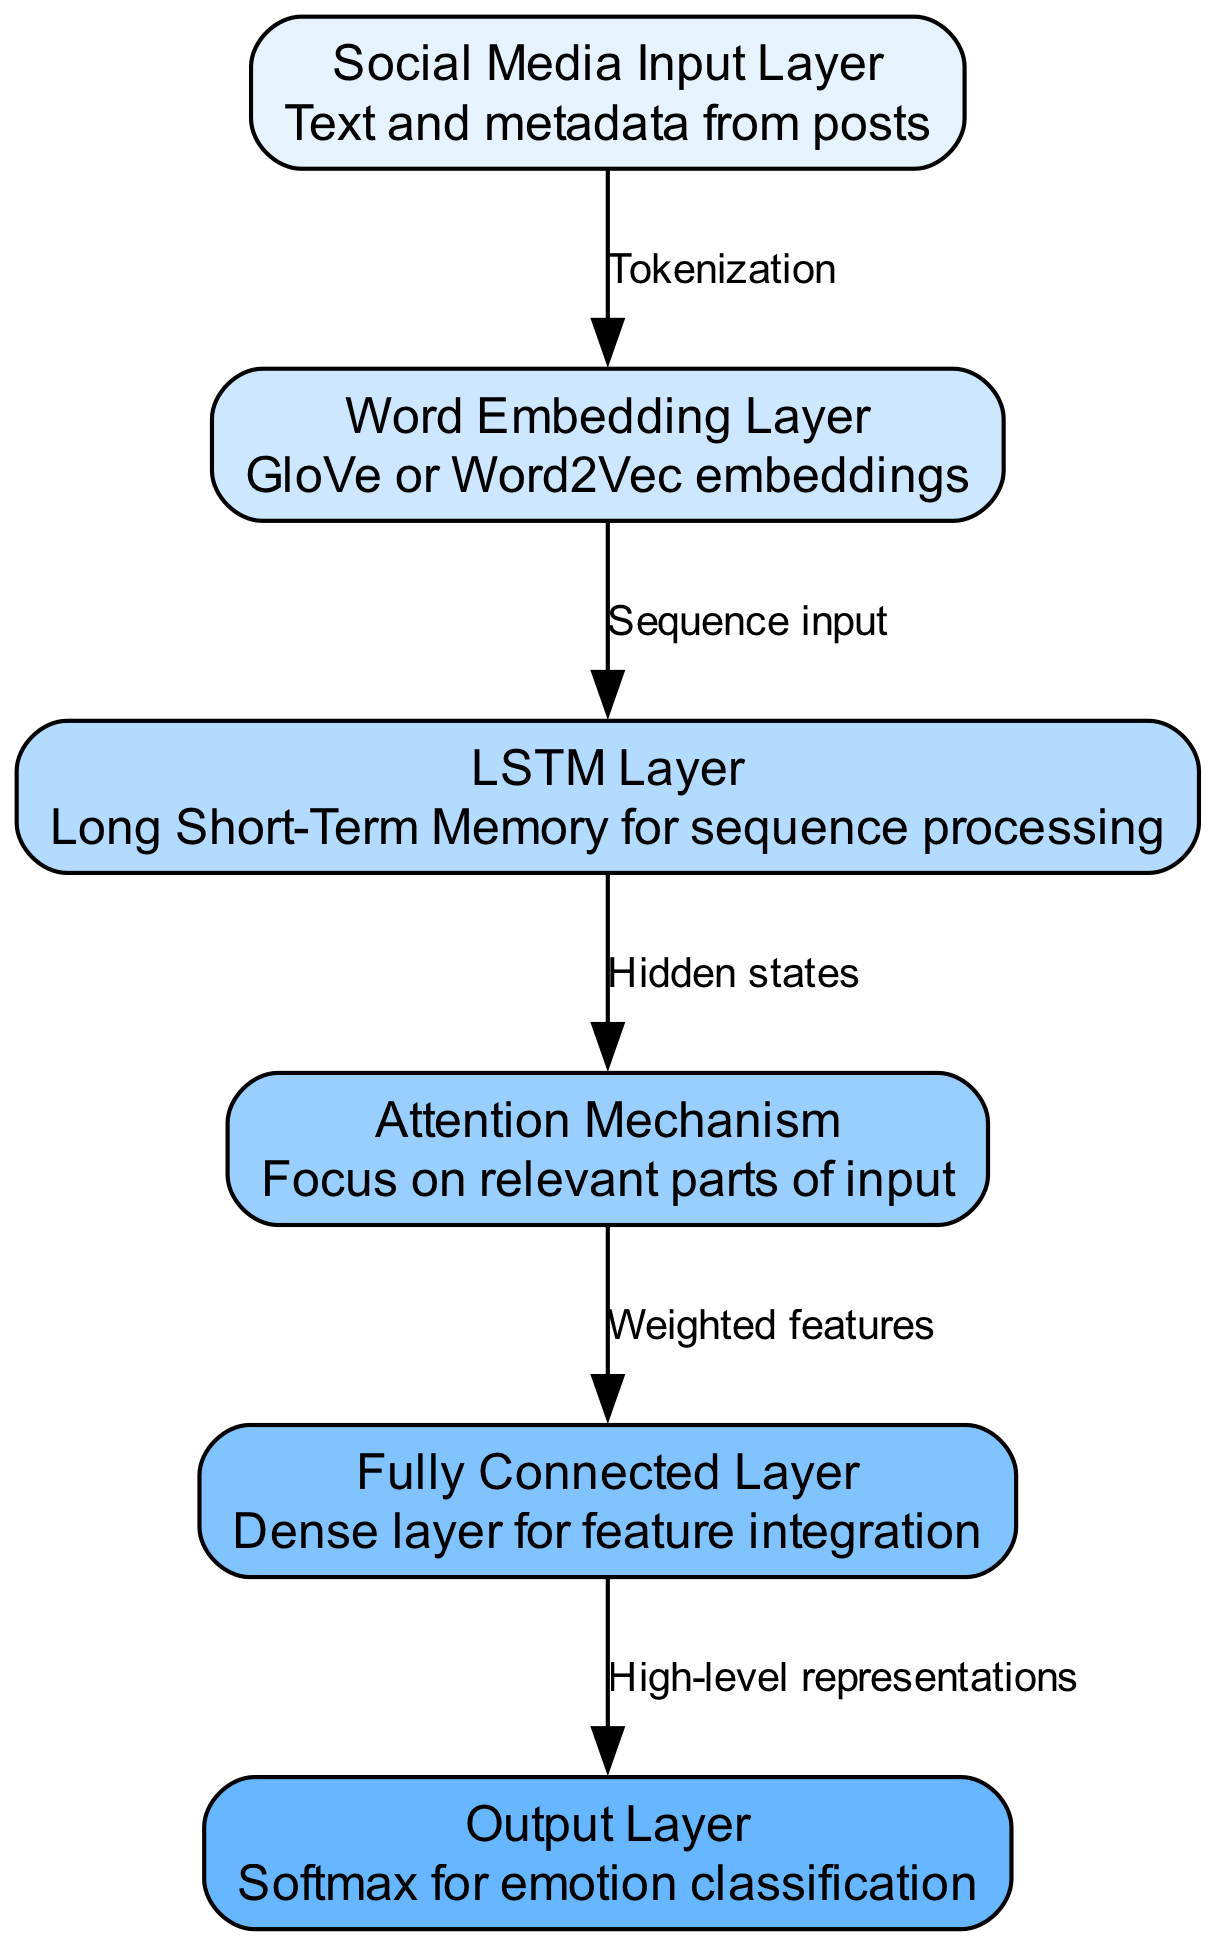What is the first layer in the architecture? The first layer, as indicated in the diagram, is the "Social Media Input Layer," which is responsible for receiving text and metadata from posts.
Answer: Social Media Input Layer How many layers are present in this neural network architecture? The diagram displays a total of six layers: Social Media Input Layer, Word Embedding Layer, LSTM Layer, Attention Mechanism, Fully Connected Layer, and Output Layer.
Answer: Six What type of embeddings does the Word Embedding Layer use? The Word Embedding Layer utilizes GloVe or Word2Vec embeddings to represent words in a numerical format for the LSTM Layer.
Answer: GloVe or Word2Vec What is the relationship between the LSTM Layer and the Attention Mechanism? The LSTM Layer outputs hidden states, which serve as the input to the Attention Mechanism, allowing it to focus on relevant parts of the input sequence.
Answer: Hidden states What processing occurs before reaching the Output Layer? Before reaching the Output Layer, the data undergoes high-level representations generated by the Fully Connected Layer, which integrates the weighted features from the Attention Mechanism.
Answer: High-level representations Which layer focuses on relevant parts of the input? The layer that emphasizes relevant input components is the Attention Mechanism, enhancing the model's focus during emotion classification.
Answer: Attention Mechanism What is the output of the model? The final output of the model, as represented in the diagram, is classified using the Softmax function in the Output Layer, resulting in specific emotion categories.
Answer: Emotion classification 